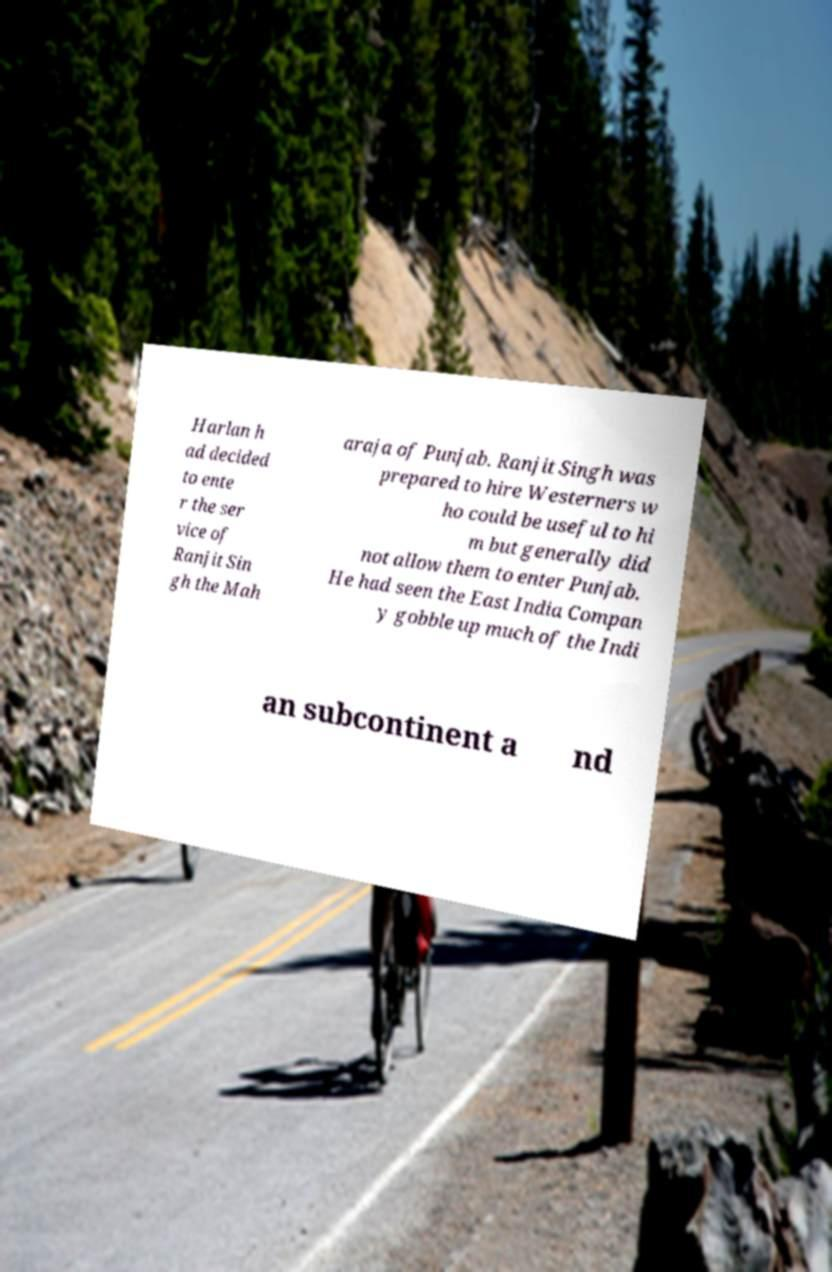Could you assist in decoding the text presented in this image and type it out clearly? Harlan h ad decided to ente r the ser vice of Ranjit Sin gh the Mah araja of Punjab. Ranjit Singh was prepared to hire Westerners w ho could be useful to hi m but generally did not allow them to enter Punjab. He had seen the East India Compan y gobble up much of the Indi an subcontinent a nd 